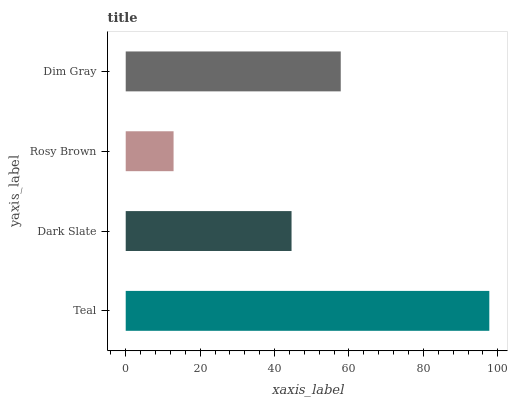Is Rosy Brown the minimum?
Answer yes or no. Yes. Is Teal the maximum?
Answer yes or no. Yes. Is Dark Slate the minimum?
Answer yes or no. No. Is Dark Slate the maximum?
Answer yes or no. No. Is Teal greater than Dark Slate?
Answer yes or no. Yes. Is Dark Slate less than Teal?
Answer yes or no. Yes. Is Dark Slate greater than Teal?
Answer yes or no. No. Is Teal less than Dark Slate?
Answer yes or no. No. Is Dim Gray the high median?
Answer yes or no. Yes. Is Dark Slate the low median?
Answer yes or no. Yes. Is Rosy Brown the high median?
Answer yes or no. No. Is Dim Gray the low median?
Answer yes or no. No. 